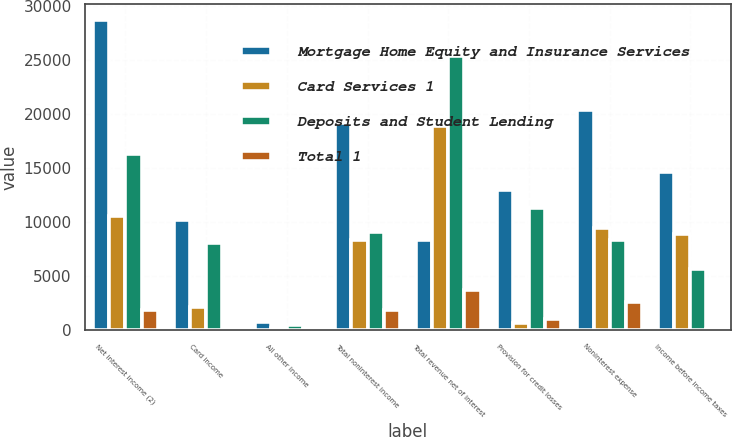<chart> <loc_0><loc_0><loc_500><loc_500><stacked_bar_chart><ecel><fcel>Net interest income (2)<fcel>Card income<fcel>All other income<fcel>Total noninterest income<fcel>Total revenue net of interest<fcel>Provision for credit losses<fcel>Noninterest expense<fcel>Income before income taxes<nl><fcel>Mortgage Home Equity and Insurance Services<fcel>28712<fcel>10194<fcel>698<fcel>19143<fcel>8302<fcel>12920<fcel>20349<fcel>14586<nl><fcel>Card Services 1<fcel>10549<fcel>2156<fcel>143<fcel>8302<fcel>18851<fcel>601<fcel>9411<fcel>8839<nl><fcel>Deposits and Student Lending<fcel>16284<fcel>8032<fcel>434<fcel>9031<fcel>25315<fcel>11305<fcel>8358<fcel>5652<nl><fcel>Total 1<fcel>1879<fcel>6<fcel>121<fcel>1810<fcel>3689<fcel>1014<fcel>2580<fcel>95<nl></chart> 